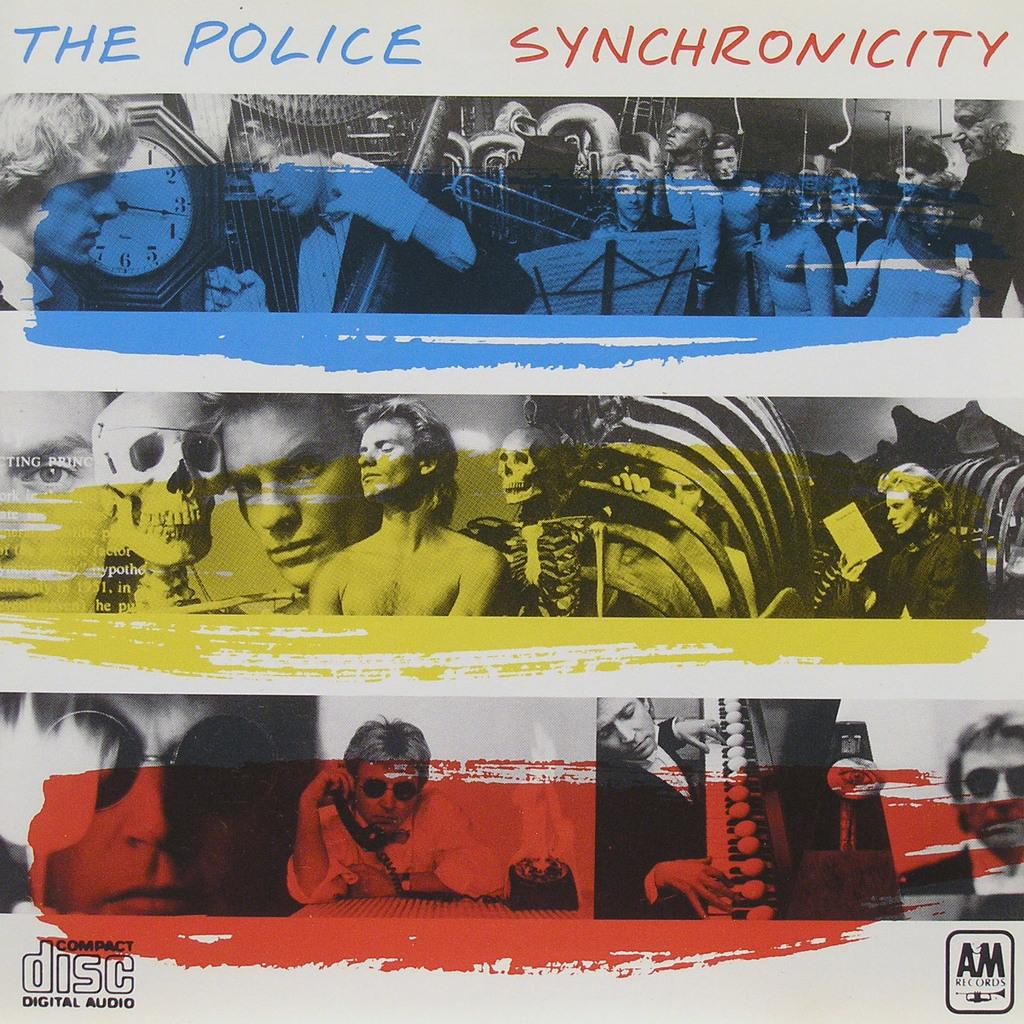<image>
Describe the image concisely. The Police Synchronicity is availble on a digital audio compact disc 